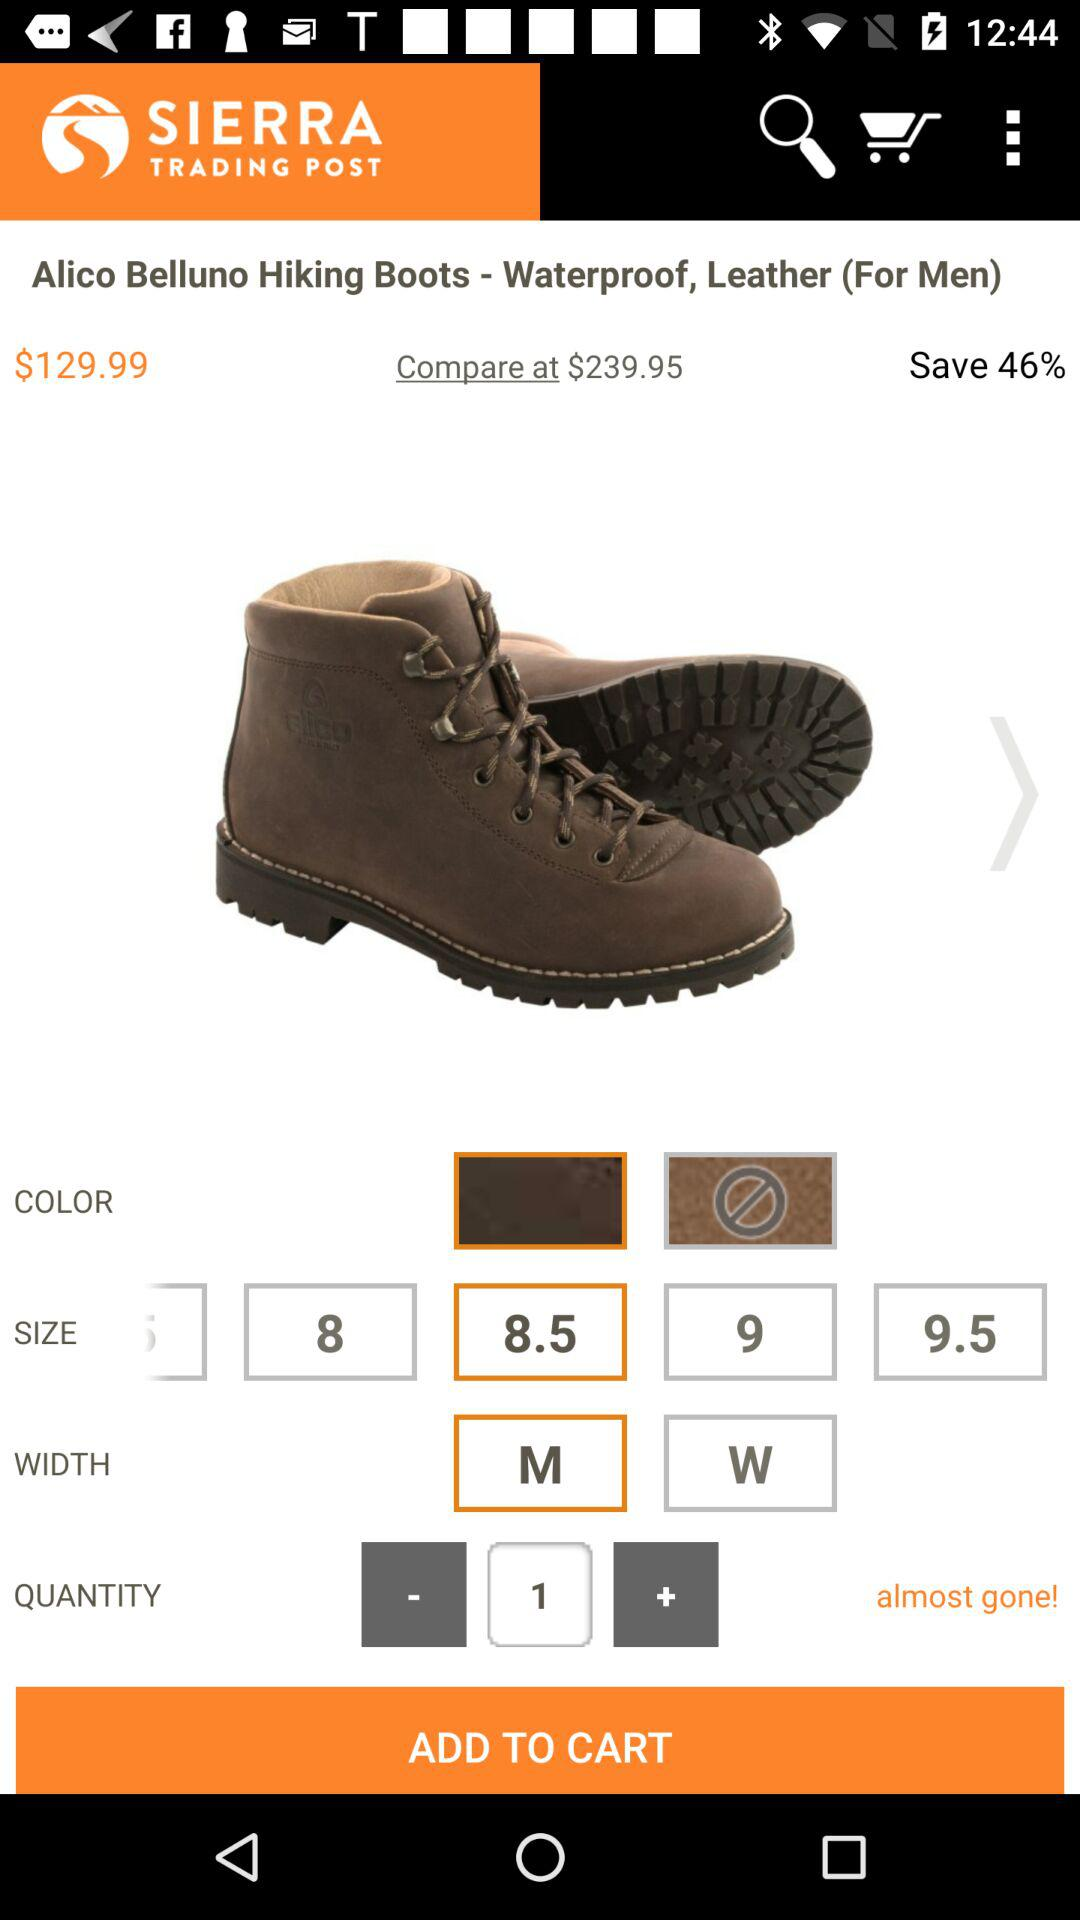What is the selected size? The selected size is 8.5. 